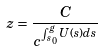Convert formula to latex. <formula><loc_0><loc_0><loc_500><loc_500>z = \frac { C } { c ^ { \int _ { s _ { 0 } } ^ { g } U ( s ) d s } }</formula> 